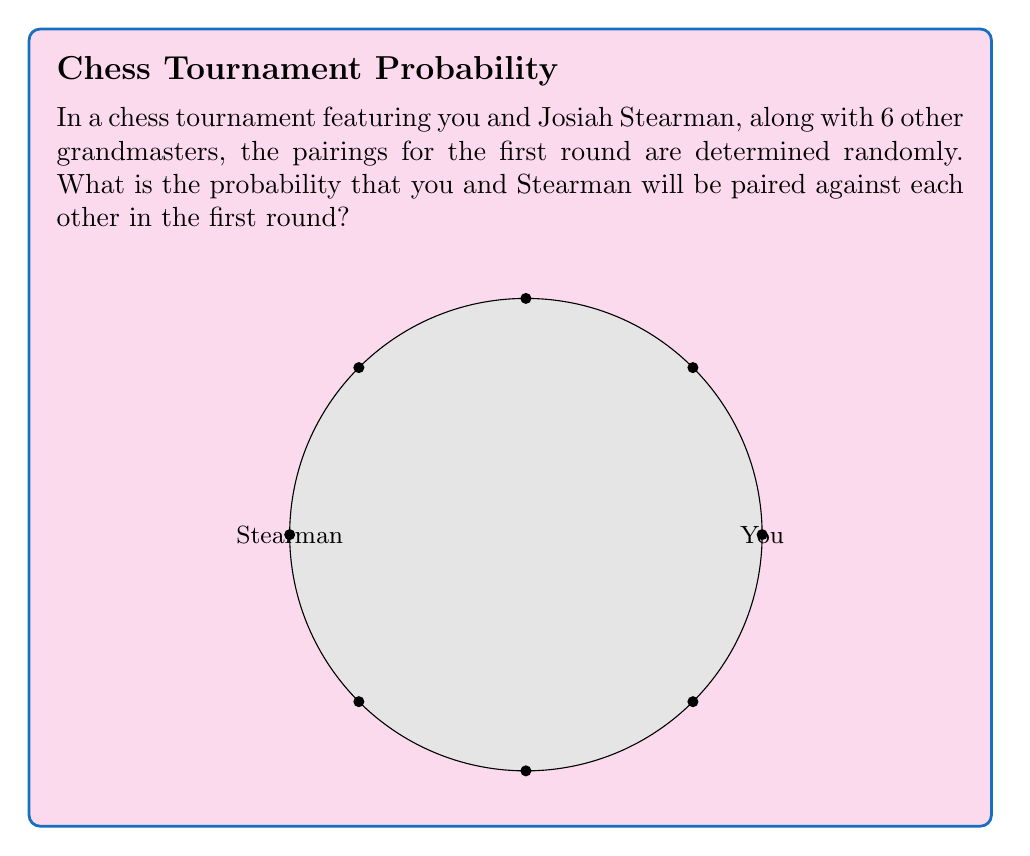Give your solution to this math problem. Let's approach this step-by-step:

1) First, we need to understand how the pairing works. In a tournament with 8 players, there will be 4 pairs in the first round.

2) The probability of you being paired with Stearman is equivalent to the probability of Stearman being your opponent out of the 7 possible opponents.

3) We can calculate this using the following formula:

   $$P(\text{paired with Stearman}) = \frac{\text{favorable outcomes}}{\text{total outcomes}} = \frac{1}{7}$$

4) To verify this, we can also calculate the total number of ways to pair 8 players and the number of ways that include you and Stearman as a pair:

   - Total number of ways to pair 8 players:
     $$\frac{8!}{2^4 \cdot 4!} = 105$$

   - Number of ways with you and Stearman paired:
     $$\frac{6!}{2^3 \cdot 3!} = 15$$

5) The probability is then:

   $$P(\text{paired with Stearman}) = \frac{15}{105} = \frac{1}{7}$$

This confirms our initial calculation.
Answer: $\frac{1}{7}$ 